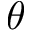<formula> <loc_0><loc_0><loc_500><loc_500>\theta</formula> 